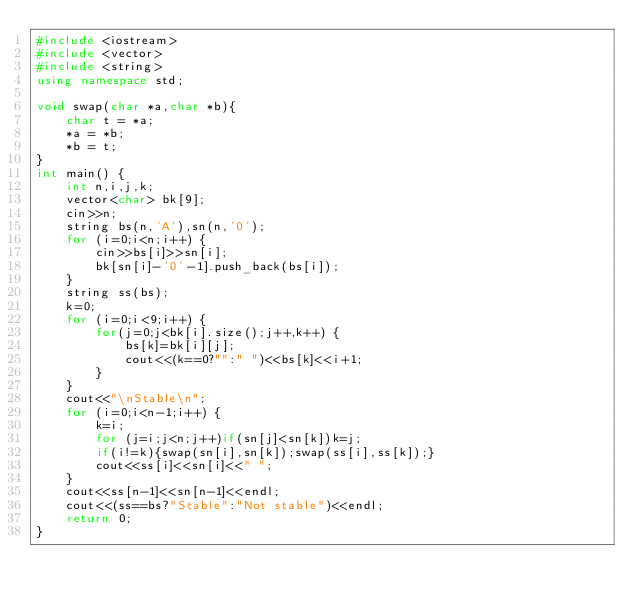Convert code to text. <code><loc_0><loc_0><loc_500><loc_500><_C++_>#include <iostream>
#include <vector>
#include <string>
using namespace std;

void swap(char *a,char *b){
    char t = *a;
    *a = *b;
    *b = t;
}
int main() {
    int n,i,j,k;
    vector<char> bk[9];
    cin>>n;
    string bs(n,'A'),sn(n,'0');
    for (i=0;i<n;i++) {
        cin>>bs[i]>>sn[i];
        bk[sn[i]-'0'-1].push_back(bs[i]);
    }
    string ss(bs);
    k=0;
    for (i=0;i<9;i++) {
        for(j=0;j<bk[i].size();j++,k++) {
            bs[k]=bk[i][j];
            cout<<(k==0?"":" ")<<bs[k]<<i+1;
        }
    }
    cout<<"\nStable\n";
    for (i=0;i<n-1;i++) {
        k=i;
        for (j=i;j<n;j++)if(sn[j]<sn[k])k=j;
        if(i!=k){swap(sn[i],sn[k]);swap(ss[i],ss[k]);}
        cout<<ss[i]<<sn[i]<<" ";
    }
    cout<<ss[n-1]<<sn[n-1]<<endl;
    cout<<(ss==bs?"Stable":"Not stable")<<endl;
    return 0;
}
</code> 